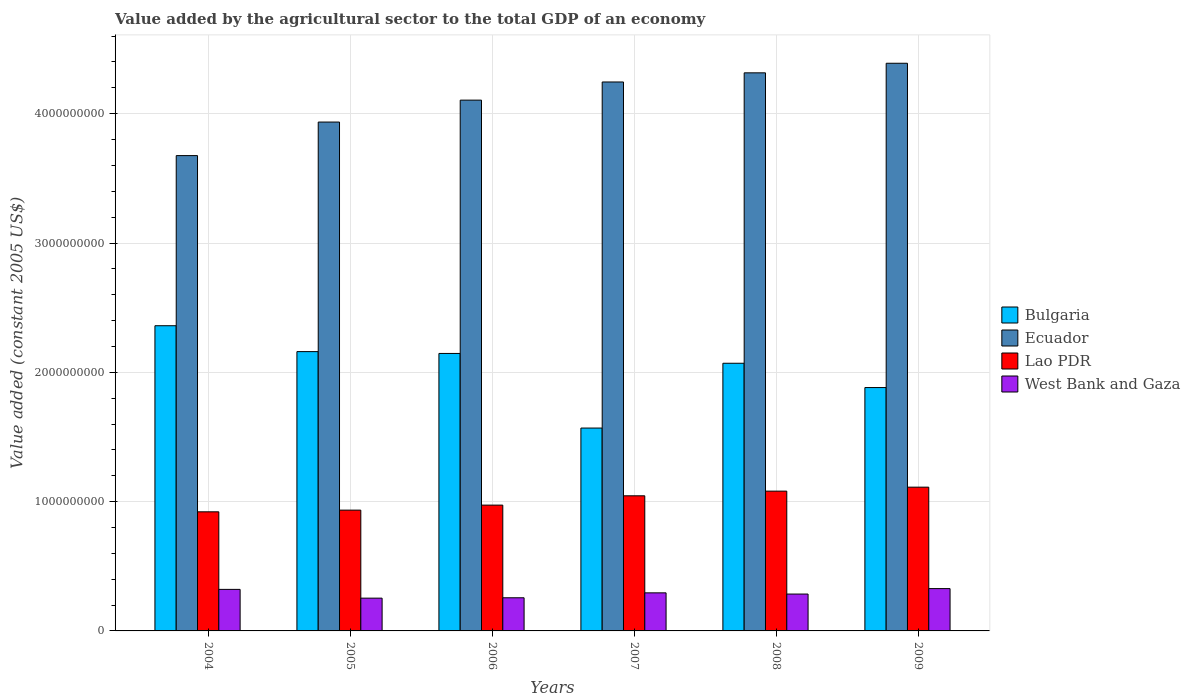How many different coloured bars are there?
Make the answer very short. 4. How many bars are there on the 4th tick from the left?
Your answer should be compact. 4. What is the label of the 3rd group of bars from the left?
Offer a terse response. 2006. What is the value added by the agricultural sector in Bulgaria in 2005?
Your answer should be very brief. 2.16e+09. Across all years, what is the maximum value added by the agricultural sector in Lao PDR?
Provide a succinct answer. 1.11e+09. Across all years, what is the minimum value added by the agricultural sector in Bulgaria?
Your answer should be very brief. 1.57e+09. In which year was the value added by the agricultural sector in Bulgaria minimum?
Your answer should be very brief. 2007. What is the total value added by the agricultural sector in Ecuador in the graph?
Give a very brief answer. 2.47e+1. What is the difference between the value added by the agricultural sector in Bulgaria in 2004 and that in 2007?
Ensure brevity in your answer.  7.91e+08. What is the difference between the value added by the agricultural sector in Ecuador in 2007 and the value added by the agricultural sector in West Bank and Gaza in 2006?
Your answer should be compact. 3.99e+09. What is the average value added by the agricultural sector in Ecuador per year?
Provide a short and direct response. 4.11e+09. In the year 2007, what is the difference between the value added by the agricultural sector in Bulgaria and value added by the agricultural sector in Lao PDR?
Give a very brief answer. 5.24e+08. What is the ratio of the value added by the agricultural sector in Ecuador in 2004 to that in 2007?
Your answer should be very brief. 0.87. Is the difference between the value added by the agricultural sector in Bulgaria in 2004 and 2005 greater than the difference between the value added by the agricultural sector in Lao PDR in 2004 and 2005?
Offer a very short reply. Yes. What is the difference between the highest and the second highest value added by the agricultural sector in Lao PDR?
Give a very brief answer. 3.06e+07. What is the difference between the highest and the lowest value added by the agricultural sector in Bulgaria?
Ensure brevity in your answer.  7.91e+08. In how many years, is the value added by the agricultural sector in West Bank and Gaza greater than the average value added by the agricultural sector in West Bank and Gaza taken over all years?
Your answer should be compact. 3. Is the sum of the value added by the agricultural sector in West Bank and Gaza in 2007 and 2008 greater than the maximum value added by the agricultural sector in Lao PDR across all years?
Ensure brevity in your answer.  No. Is it the case that in every year, the sum of the value added by the agricultural sector in Bulgaria and value added by the agricultural sector in Lao PDR is greater than the sum of value added by the agricultural sector in West Bank and Gaza and value added by the agricultural sector in Ecuador?
Your answer should be very brief. Yes. What does the 1st bar from the left in 2006 represents?
Your answer should be compact. Bulgaria. What does the 3rd bar from the right in 2008 represents?
Give a very brief answer. Ecuador. Is it the case that in every year, the sum of the value added by the agricultural sector in Bulgaria and value added by the agricultural sector in West Bank and Gaza is greater than the value added by the agricultural sector in Lao PDR?
Offer a very short reply. Yes. How many years are there in the graph?
Your response must be concise. 6. How many legend labels are there?
Make the answer very short. 4. What is the title of the graph?
Your response must be concise. Value added by the agricultural sector to the total GDP of an economy. Does "China" appear as one of the legend labels in the graph?
Keep it short and to the point. No. What is the label or title of the X-axis?
Your answer should be compact. Years. What is the label or title of the Y-axis?
Your answer should be compact. Value added (constant 2005 US$). What is the Value added (constant 2005 US$) in Bulgaria in 2004?
Your response must be concise. 2.36e+09. What is the Value added (constant 2005 US$) of Ecuador in 2004?
Your answer should be compact. 3.68e+09. What is the Value added (constant 2005 US$) in Lao PDR in 2004?
Keep it short and to the point. 9.21e+08. What is the Value added (constant 2005 US$) in West Bank and Gaza in 2004?
Provide a short and direct response. 3.21e+08. What is the Value added (constant 2005 US$) in Bulgaria in 2005?
Ensure brevity in your answer.  2.16e+09. What is the Value added (constant 2005 US$) of Ecuador in 2005?
Your answer should be compact. 3.94e+09. What is the Value added (constant 2005 US$) of Lao PDR in 2005?
Make the answer very short. 9.34e+08. What is the Value added (constant 2005 US$) in West Bank and Gaza in 2005?
Give a very brief answer. 2.53e+08. What is the Value added (constant 2005 US$) in Bulgaria in 2006?
Your answer should be very brief. 2.15e+09. What is the Value added (constant 2005 US$) of Ecuador in 2006?
Make the answer very short. 4.10e+09. What is the Value added (constant 2005 US$) of Lao PDR in 2006?
Give a very brief answer. 9.73e+08. What is the Value added (constant 2005 US$) of West Bank and Gaza in 2006?
Offer a terse response. 2.56e+08. What is the Value added (constant 2005 US$) of Bulgaria in 2007?
Your response must be concise. 1.57e+09. What is the Value added (constant 2005 US$) of Ecuador in 2007?
Make the answer very short. 4.25e+09. What is the Value added (constant 2005 US$) in Lao PDR in 2007?
Your answer should be compact. 1.04e+09. What is the Value added (constant 2005 US$) in West Bank and Gaza in 2007?
Your answer should be very brief. 2.94e+08. What is the Value added (constant 2005 US$) of Bulgaria in 2008?
Your answer should be compact. 2.07e+09. What is the Value added (constant 2005 US$) in Ecuador in 2008?
Your response must be concise. 4.32e+09. What is the Value added (constant 2005 US$) in Lao PDR in 2008?
Offer a terse response. 1.08e+09. What is the Value added (constant 2005 US$) of West Bank and Gaza in 2008?
Provide a succinct answer. 2.85e+08. What is the Value added (constant 2005 US$) in Bulgaria in 2009?
Your answer should be compact. 1.88e+09. What is the Value added (constant 2005 US$) in Ecuador in 2009?
Provide a succinct answer. 4.39e+09. What is the Value added (constant 2005 US$) of Lao PDR in 2009?
Ensure brevity in your answer.  1.11e+09. What is the Value added (constant 2005 US$) in West Bank and Gaza in 2009?
Your answer should be compact. 3.27e+08. Across all years, what is the maximum Value added (constant 2005 US$) of Bulgaria?
Make the answer very short. 2.36e+09. Across all years, what is the maximum Value added (constant 2005 US$) of Ecuador?
Offer a very short reply. 4.39e+09. Across all years, what is the maximum Value added (constant 2005 US$) of Lao PDR?
Make the answer very short. 1.11e+09. Across all years, what is the maximum Value added (constant 2005 US$) in West Bank and Gaza?
Your response must be concise. 3.27e+08. Across all years, what is the minimum Value added (constant 2005 US$) of Bulgaria?
Your response must be concise. 1.57e+09. Across all years, what is the minimum Value added (constant 2005 US$) in Ecuador?
Give a very brief answer. 3.68e+09. Across all years, what is the minimum Value added (constant 2005 US$) of Lao PDR?
Give a very brief answer. 9.21e+08. Across all years, what is the minimum Value added (constant 2005 US$) of West Bank and Gaza?
Provide a succinct answer. 2.53e+08. What is the total Value added (constant 2005 US$) of Bulgaria in the graph?
Your response must be concise. 1.22e+1. What is the total Value added (constant 2005 US$) in Ecuador in the graph?
Your response must be concise. 2.47e+1. What is the total Value added (constant 2005 US$) of Lao PDR in the graph?
Ensure brevity in your answer.  6.07e+09. What is the total Value added (constant 2005 US$) in West Bank and Gaza in the graph?
Ensure brevity in your answer.  1.74e+09. What is the difference between the Value added (constant 2005 US$) in Bulgaria in 2004 and that in 2005?
Provide a succinct answer. 2.00e+08. What is the difference between the Value added (constant 2005 US$) in Ecuador in 2004 and that in 2005?
Offer a terse response. -2.59e+08. What is the difference between the Value added (constant 2005 US$) of Lao PDR in 2004 and that in 2005?
Your response must be concise. -1.30e+07. What is the difference between the Value added (constant 2005 US$) of West Bank and Gaza in 2004 and that in 2005?
Your response must be concise. 6.79e+07. What is the difference between the Value added (constant 2005 US$) in Bulgaria in 2004 and that in 2006?
Your answer should be very brief. 2.14e+08. What is the difference between the Value added (constant 2005 US$) in Ecuador in 2004 and that in 2006?
Offer a very short reply. -4.29e+08. What is the difference between the Value added (constant 2005 US$) in Lao PDR in 2004 and that in 2006?
Offer a very short reply. -5.19e+07. What is the difference between the Value added (constant 2005 US$) in West Bank and Gaza in 2004 and that in 2006?
Make the answer very short. 6.50e+07. What is the difference between the Value added (constant 2005 US$) of Bulgaria in 2004 and that in 2007?
Give a very brief answer. 7.91e+08. What is the difference between the Value added (constant 2005 US$) of Ecuador in 2004 and that in 2007?
Keep it short and to the point. -5.69e+08. What is the difference between the Value added (constant 2005 US$) in Lao PDR in 2004 and that in 2007?
Your response must be concise. -1.24e+08. What is the difference between the Value added (constant 2005 US$) of West Bank and Gaza in 2004 and that in 2007?
Your answer should be very brief. 2.69e+07. What is the difference between the Value added (constant 2005 US$) of Bulgaria in 2004 and that in 2008?
Your response must be concise. 2.90e+08. What is the difference between the Value added (constant 2005 US$) in Ecuador in 2004 and that in 2008?
Provide a short and direct response. -6.40e+08. What is the difference between the Value added (constant 2005 US$) in Lao PDR in 2004 and that in 2008?
Provide a short and direct response. -1.60e+08. What is the difference between the Value added (constant 2005 US$) of West Bank and Gaza in 2004 and that in 2008?
Offer a very short reply. 3.62e+07. What is the difference between the Value added (constant 2005 US$) of Bulgaria in 2004 and that in 2009?
Give a very brief answer. 4.78e+08. What is the difference between the Value added (constant 2005 US$) in Ecuador in 2004 and that in 2009?
Your response must be concise. -7.14e+08. What is the difference between the Value added (constant 2005 US$) of Lao PDR in 2004 and that in 2009?
Provide a succinct answer. -1.91e+08. What is the difference between the Value added (constant 2005 US$) of West Bank and Gaza in 2004 and that in 2009?
Offer a very short reply. -6.01e+06. What is the difference between the Value added (constant 2005 US$) in Bulgaria in 2005 and that in 2006?
Make the answer very short. 1.41e+07. What is the difference between the Value added (constant 2005 US$) of Ecuador in 2005 and that in 2006?
Give a very brief answer. -1.70e+08. What is the difference between the Value added (constant 2005 US$) in Lao PDR in 2005 and that in 2006?
Keep it short and to the point. -3.88e+07. What is the difference between the Value added (constant 2005 US$) of West Bank and Gaza in 2005 and that in 2006?
Your response must be concise. -2.89e+06. What is the difference between the Value added (constant 2005 US$) of Bulgaria in 2005 and that in 2007?
Keep it short and to the point. 5.91e+08. What is the difference between the Value added (constant 2005 US$) of Ecuador in 2005 and that in 2007?
Give a very brief answer. -3.10e+08. What is the difference between the Value added (constant 2005 US$) of Lao PDR in 2005 and that in 2007?
Your answer should be compact. -1.11e+08. What is the difference between the Value added (constant 2005 US$) in West Bank and Gaza in 2005 and that in 2007?
Offer a very short reply. -4.09e+07. What is the difference between the Value added (constant 2005 US$) of Bulgaria in 2005 and that in 2008?
Offer a very short reply. 9.00e+07. What is the difference between the Value added (constant 2005 US$) in Ecuador in 2005 and that in 2008?
Provide a succinct answer. -3.81e+08. What is the difference between the Value added (constant 2005 US$) of Lao PDR in 2005 and that in 2008?
Your response must be concise. -1.47e+08. What is the difference between the Value added (constant 2005 US$) in West Bank and Gaza in 2005 and that in 2008?
Your response must be concise. -3.17e+07. What is the difference between the Value added (constant 2005 US$) in Bulgaria in 2005 and that in 2009?
Give a very brief answer. 2.78e+08. What is the difference between the Value added (constant 2005 US$) in Ecuador in 2005 and that in 2009?
Your answer should be compact. -4.55e+08. What is the difference between the Value added (constant 2005 US$) of Lao PDR in 2005 and that in 2009?
Ensure brevity in your answer.  -1.78e+08. What is the difference between the Value added (constant 2005 US$) of West Bank and Gaza in 2005 and that in 2009?
Your response must be concise. -7.39e+07. What is the difference between the Value added (constant 2005 US$) of Bulgaria in 2006 and that in 2007?
Offer a terse response. 5.77e+08. What is the difference between the Value added (constant 2005 US$) of Ecuador in 2006 and that in 2007?
Ensure brevity in your answer.  -1.40e+08. What is the difference between the Value added (constant 2005 US$) of Lao PDR in 2006 and that in 2007?
Keep it short and to the point. -7.20e+07. What is the difference between the Value added (constant 2005 US$) of West Bank and Gaza in 2006 and that in 2007?
Offer a very short reply. -3.81e+07. What is the difference between the Value added (constant 2005 US$) in Bulgaria in 2006 and that in 2008?
Your response must be concise. 7.59e+07. What is the difference between the Value added (constant 2005 US$) in Ecuador in 2006 and that in 2008?
Your answer should be compact. -2.11e+08. What is the difference between the Value added (constant 2005 US$) in Lao PDR in 2006 and that in 2008?
Offer a very short reply. -1.08e+08. What is the difference between the Value added (constant 2005 US$) of West Bank and Gaza in 2006 and that in 2008?
Provide a succinct answer. -2.88e+07. What is the difference between the Value added (constant 2005 US$) in Bulgaria in 2006 and that in 2009?
Make the answer very short. 2.64e+08. What is the difference between the Value added (constant 2005 US$) of Ecuador in 2006 and that in 2009?
Provide a succinct answer. -2.85e+08. What is the difference between the Value added (constant 2005 US$) in Lao PDR in 2006 and that in 2009?
Make the answer very short. -1.39e+08. What is the difference between the Value added (constant 2005 US$) in West Bank and Gaza in 2006 and that in 2009?
Give a very brief answer. -7.10e+07. What is the difference between the Value added (constant 2005 US$) in Bulgaria in 2007 and that in 2008?
Provide a succinct answer. -5.01e+08. What is the difference between the Value added (constant 2005 US$) in Ecuador in 2007 and that in 2008?
Keep it short and to the point. -7.08e+07. What is the difference between the Value added (constant 2005 US$) of Lao PDR in 2007 and that in 2008?
Provide a short and direct response. -3.61e+07. What is the difference between the Value added (constant 2005 US$) in West Bank and Gaza in 2007 and that in 2008?
Offer a very short reply. 9.26e+06. What is the difference between the Value added (constant 2005 US$) in Bulgaria in 2007 and that in 2009?
Your answer should be very brief. -3.13e+08. What is the difference between the Value added (constant 2005 US$) of Ecuador in 2007 and that in 2009?
Provide a succinct answer. -1.45e+08. What is the difference between the Value added (constant 2005 US$) in Lao PDR in 2007 and that in 2009?
Your response must be concise. -6.67e+07. What is the difference between the Value added (constant 2005 US$) of West Bank and Gaza in 2007 and that in 2009?
Make the answer very short. -3.29e+07. What is the difference between the Value added (constant 2005 US$) in Bulgaria in 2008 and that in 2009?
Ensure brevity in your answer.  1.88e+08. What is the difference between the Value added (constant 2005 US$) of Ecuador in 2008 and that in 2009?
Your answer should be compact. -7.40e+07. What is the difference between the Value added (constant 2005 US$) in Lao PDR in 2008 and that in 2009?
Keep it short and to the point. -3.06e+07. What is the difference between the Value added (constant 2005 US$) in West Bank and Gaza in 2008 and that in 2009?
Offer a terse response. -4.22e+07. What is the difference between the Value added (constant 2005 US$) of Bulgaria in 2004 and the Value added (constant 2005 US$) of Ecuador in 2005?
Your response must be concise. -1.58e+09. What is the difference between the Value added (constant 2005 US$) in Bulgaria in 2004 and the Value added (constant 2005 US$) in Lao PDR in 2005?
Make the answer very short. 1.43e+09. What is the difference between the Value added (constant 2005 US$) of Bulgaria in 2004 and the Value added (constant 2005 US$) of West Bank and Gaza in 2005?
Keep it short and to the point. 2.11e+09. What is the difference between the Value added (constant 2005 US$) in Ecuador in 2004 and the Value added (constant 2005 US$) in Lao PDR in 2005?
Offer a very short reply. 2.74e+09. What is the difference between the Value added (constant 2005 US$) of Ecuador in 2004 and the Value added (constant 2005 US$) of West Bank and Gaza in 2005?
Make the answer very short. 3.42e+09. What is the difference between the Value added (constant 2005 US$) in Lao PDR in 2004 and the Value added (constant 2005 US$) in West Bank and Gaza in 2005?
Offer a very short reply. 6.68e+08. What is the difference between the Value added (constant 2005 US$) in Bulgaria in 2004 and the Value added (constant 2005 US$) in Ecuador in 2006?
Your response must be concise. -1.74e+09. What is the difference between the Value added (constant 2005 US$) in Bulgaria in 2004 and the Value added (constant 2005 US$) in Lao PDR in 2006?
Offer a terse response. 1.39e+09. What is the difference between the Value added (constant 2005 US$) of Bulgaria in 2004 and the Value added (constant 2005 US$) of West Bank and Gaza in 2006?
Provide a short and direct response. 2.10e+09. What is the difference between the Value added (constant 2005 US$) in Ecuador in 2004 and the Value added (constant 2005 US$) in Lao PDR in 2006?
Provide a short and direct response. 2.70e+09. What is the difference between the Value added (constant 2005 US$) in Ecuador in 2004 and the Value added (constant 2005 US$) in West Bank and Gaza in 2006?
Ensure brevity in your answer.  3.42e+09. What is the difference between the Value added (constant 2005 US$) of Lao PDR in 2004 and the Value added (constant 2005 US$) of West Bank and Gaza in 2006?
Make the answer very short. 6.65e+08. What is the difference between the Value added (constant 2005 US$) of Bulgaria in 2004 and the Value added (constant 2005 US$) of Ecuador in 2007?
Your answer should be very brief. -1.88e+09. What is the difference between the Value added (constant 2005 US$) of Bulgaria in 2004 and the Value added (constant 2005 US$) of Lao PDR in 2007?
Offer a very short reply. 1.32e+09. What is the difference between the Value added (constant 2005 US$) in Bulgaria in 2004 and the Value added (constant 2005 US$) in West Bank and Gaza in 2007?
Your answer should be compact. 2.07e+09. What is the difference between the Value added (constant 2005 US$) in Ecuador in 2004 and the Value added (constant 2005 US$) in Lao PDR in 2007?
Your response must be concise. 2.63e+09. What is the difference between the Value added (constant 2005 US$) in Ecuador in 2004 and the Value added (constant 2005 US$) in West Bank and Gaza in 2007?
Your answer should be very brief. 3.38e+09. What is the difference between the Value added (constant 2005 US$) in Lao PDR in 2004 and the Value added (constant 2005 US$) in West Bank and Gaza in 2007?
Give a very brief answer. 6.27e+08. What is the difference between the Value added (constant 2005 US$) of Bulgaria in 2004 and the Value added (constant 2005 US$) of Ecuador in 2008?
Provide a short and direct response. -1.96e+09. What is the difference between the Value added (constant 2005 US$) of Bulgaria in 2004 and the Value added (constant 2005 US$) of Lao PDR in 2008?
Make the answer very short. 1.28e+09. What is the difference between the Value added (constant 2005 US$) in Bulgaria in 2004 and the Value added (constant 2005 US$) in West Bank and Gaza in 2008?
Make the answer very short. 2.08e+09. What is the difference between the Value added (constant 2005 US$) of Ecuador in 2004 and the Value added (constant 2005 US$) of Lao PDR in 2008?
Make the answer very short. 2.59e+09. What is the difference between the Value added (constant 2005 US$) in Ecuador in 2004 and the Value added (constant 2005 US$) in West Bank and Gaza in 2008?
Your answer should be very brief. 3.39e+09. What is the difference between the Value added (constant 2005 US$) in Lao PDR in 2004 and the Value added (constant 2005 US$) in West Bank and Gaza in 2008?
Ensure brevity in your answer.  6.36e+08. What is the difference between the Value added (constant 2005 US$) of Bulgaria in 2004 and the Value added (constant 2005 US$) of Ecuador in 2009?
Your response must be concise. -2.03e+09. What is the difference between the Value added (constant 2005 US$) in Bulgaria in 2004 and the Value added (constant 2005 US$) in Lao PDR in 2009?
Offer a terse response. 1.25e+09. What is the difference between the Value added (constant 2005 US$) in Bulgaria in 2004 and the Value added (constant 2005 US$) in West Bank and Gaza in 2009?
Your answer should be very brief. 2.03e+09. What is the difference between the Value added (constant 2005 US$) in Ecuador in 2004 and the Value added (constant 2005 US$) in Lao PDR in 2009?
Offer a terse response. 2.56e+09. What is the difference between the Value added (constant 2005 US$) of Ecuador in 2004 and the Value added (constant 2005 US$) of West Bank and Gaza in 2009?
Give a very brief answer. 3.35e+09. What is the difference between the Value added (constant 2005 US$) of Lao PDR in 2004 and the Value added (constant 2005 US$) of West Bank and Gaza in 2009?
Keep it short and to the point. 5.94e+08. What is the difference between the Value added (constant 2005 US$) of Bulgaria in 2005 and the Value added (constant 2005 US$) of Ecuador in 2006?
Give a very brief answer. -1.94e+09. What is the difference between the Value added (constant 2005 US$) in Bulgaria in 2005 and the Value added (constant 2005 US$) in Lao PDR in 2006?
Offer a very short reply. 1.19e+09. What is the difference between the Value added (constant 2005 US$) of Bulgaria in 2005 and the Value added (constant 2005 US$) of West Bank and Gaza in 2006?
Your response must be concise. 1.90e+09. What is the difference between the Value added (constant 2005 US$) of Ecuador in 2005 and the Value added (constant 2005 US$) of Lao PDR in 2006?
Offer a very short reply. 2.96e+09. What is the difference between the Value added (constant 2005 US$) of Ecuador in 2005 and the Value added (constant 2005 US$) of West Bank and Gaza in 2006?
Give a very brief answer. 3.68e+09. What is the difference between the Value added (constant 2005 US$) in Lao PDR in 2005 and the Value added (constant 2005 US$) in West Bank and Gaza in 2006?
Offer a terse response. 6.78e+08. What is the difference between the Value added (constant 2005 US$) of Bulgaria in 2005 and the Value added (constant 2005 US$) of Ecuador in 2007?
Provide a short and direct response. -2.09e+09. What is the difference between the Value added (constant 2005 US$) of Bulgaria in 2005 and the Value added (constant 2005 US$) of Lao PDR in 2007?
Provide a short and direct response. 1.12e+09. What is the difference between the Value added (constant 2005 US$) in Bulgaria in 2005 and the Value added (constant 2005 US$) in West Bank and Gaza in 2007?
Your answer should be compact. 1.87e+09. What is the difference between the Value added (constant 2005 US$) in Ecuador in 2005 and the Value added (constant 2005 US$) in Lao PDR in 2007?
Make the answer very short. 2.89e+09. What is the difference between the Value added (constant 2005 US$) of Ecuador in 2005 and the Value added (constant 2005 US$) of West Bank and Gaza in 2007?
Give a very brief answer. 3.64e+09. What is the difference between the Value added (constant 2005 US$) of Lao PDR in 2005 and the Value added (constant 2005 US$) of West Bank and Gaza in 2007?
Provide a succinct answer. 6.40e+08. What is the difference between the Value added (constant 2005 US$) in Bulgaria in 2005 and the Value added (constant 2005 US$) in Ecuador in 2008?
Offer a terse response. -2.16e+09. What is the difference between the Value added (constant 2005 US$) of Bulgaria in 2005 and the Value added (constant 2005 US$) of Lao PDR in 2008?
Provide a succinct answer. 1.08e+09. What is the difference between the Value added (constant 2005 US$) in Bulgaria in 2005 and the Value added (constant 2005 US$) in West Bank and Gaza in 2008?
Give a very brief answer. 1.87e+09. What is the difference between the Value added (constant 2005 US$) of Ecuador in 2005 and the Value added (constant 2005 US$) of Lao PDR in 2008?
Your answer should be compact. 2.85e+09. What is the difference between the Value added (constant 2005 US$) of Ecuador in 2005 and the Value added (constant 2005 US$) of West Bank and Gaza in 2008?
Offer a terse response. 3.65e+09. What is the difference between the Value added (constant 2005 US$) in Lao PDR in 2005 and the Value added (constant 2005 US$) in West Bank and Gaza in 2008?
Your response must be concise. 6.49e+08. What is the difference between the Value added (constant 2005 US$) in Bulgaria in 2005 and the Value added (constant 2005 US$) in Ecuador in 2009?
Provide a short and direct response. -2.23e+09. What is the difference between the Value added (constant 2005 US$) of Bulgaria in 2005 and the Value added (constant 2005 US$) of Lao PDR in 2009?
Give a very brief answer. 1.05e+09. What is the difference between the Value added (constant 2005 US$) in Bulgaria in 2005 and the Value added (constant 2005 US$) in West Bank and Gaza in 2009?
Give a very brief answer. 1.83e+09. What is the difference between the Value added (constant 2005 US$) of Ecuador in 2005 and the Value added (constant 2005 US$) of Lao PDR in 2009?
Keep it short and to the point. 2.82e+09. What is the difference between the Value added (constant 2005 US$) in Ecuador in 2005 and the Value added (constant 2005 US$) in West Bank and Gaza in 2009?
Your answer should be compact. 3.61e+09. What is the difference between the Value added (constant 2005 US$) of Lao PDR in 2005 and the Value added (constant 2005 US$) of West Bank and Gaza in 2009?
Give a very brief answer. 6.07e+08. What is the difference between the Value added (constant 2005 US$) of Bulgaria in 2006 and the Value added (constant 2005 US$) of Ecuador in 2007?
Your response must be concise. -2.10e+09. What is the difference between the Value added (constant 2005 US$) in Bulgaria in 2006 and the Value added (constant 2005 US$) in Lao PDR in 2007?
Offer a terse response. 1.10e+09. What is the difference between the Value added (constant 2005 US$) of Bulgaria in 2006 and the Value added (constant 2005 US$) of West Bank and Gaza in 2007?
Offer a terse response. 1.85e+09. What is the difference between the Value added (constant 2005 US$) of Ecuador in 2006 and the Value added (constant 2005 US$) of Lao PDR in 2007?
Provide a succinct answer. 3.06e+09. What is the difference between the Value added (constant 2005 US$) in Ecuador in 2006 and the Value added (constant 2005 US$) in West Bank and Gaza in 2007?
Your answer should be compact. 3.81e+09. What is the difference between the Value added (constant 2005 US$) in Lao PDR in 2006 and the Value added (constant 2005 US$) in West Bank and Gaza in 2007?
Your answer should be very brief. 6.79e+08. What is the difference between the Value added (constant 2005 US$) in Bulgaria in 2006 and the Value added (constant 2005 US$) in Ecuador in 2008?
Your answer should be compact. -2.17e+09. What is the difference between the Value added (constant 2005 US$) of Bulgaria in 2006 and the Value added (constant 2005 US$) of Lao PDR in 2008?
Your answer should be very brief. 1.06e+09. What is the difference between the Value added (constant 2005 US$) in Bulgaria in 2006 and the Value added (constant 2005 US$) in West Bank and Gaza in 2008?
Provide a short and direct response. 1.86e+09. What is the difference between the Value added (constant 2005 US$) in Ecuador in 2006 and the Value added (constant 2005 US$) in Lao PDR in 2008?
Provide a succinct answer. 3.02e+09. What is the difference between the Value added (constant 2005 US$) of Ecuador in 2006 and the Value added (constant 2005 US$) of West Bank and Gaza in 2008?
Provide a succinct answer. 3.82e+09. What is the difference between the Value added (constant 2005 US$) in Lao PDR in 2006 and the Value added (constant 2005 US$) in West Bank and Gaza in 2008?
Offer a very short reply. 6.88e+08. What is the difference between the Value added (constant 2005 US$) in Bulgaria in 2006 and the Value added (constant 2005 US$) in Ecuador in 2009?
Provide a short and direct response. -2.24e+09. What is the difference between the Value added (constant 2005 US$) in Bulgaria in 2006 and the Value added (constant 2005 US$) in Lao PDR in 2009?
Your response must be concise. 1.03e+09. What is the difference between the Value added (constant 2005 US$) in Bulgaria in 2006 and the Value added (constant 2005 US$) in West Bank and Gaza in 2009?
Your answer should be very brief. 1.82e+09. What is the difference between the Value added (constant 2005 US$) of Ecuador in 2006 and the Value added (constant 2005 US$) of Lao PDR in 2009?
Your answer should be compact. 2.99e+09. What is the difference between the Value added (constant 2005 US$) in Ecuador in 2006 and the Value added (constant 2005 US$) in West Bank and Gaza in 2009?
Give a very brief answer. 3.78e+09. What is the difference between the Value added (constant 2005 US$) of Lao PDR in 2006 and the Value added (constant 2005 US$) of West Bank and Gaza in 2009?
Keep it short and to the point. 6.46e+08. What is the difference between the Value added (constant 2005 US$) in Bulgaria in 2007 and the Value added (constant 2005 US$) in Ecuador in 2008?
Your response must be concise. -2.75e+09. What is the difference between the Value added (constant 2005 US$) of Bulgaria in 2007 and the Value added (constant 2005 US$) of Lao PDR in 2008?
Your answer should be very brief. 4.88e+08. What is the difference between the Value added (constant 2005 US$) of Bulgaria in 2007 and the Value added (constant 2005 US$) of West Bank and Gaza in 2008?
Your answer should be compact. 1.28e+09. What is the difference between the Value added (constant 2005 US$) of Ecuador in 2007 and the Value added (constant 2005 US$) of Lao PDR in 2008?
Give a very brief answer. 3.16e+09. What is the difference between the Value added (constant 2005 US$) of Ecuador in 2007 and the Value added (constant 2005 US$) of West Bank and Gaza in 2008?
Provide a succinct answer. 3.96e+09. What is the difference between the Value added (constant 2005 US$) of Lao PDR in 2007 and the Value added (constant 2005 US$) of West Bank and Gaza in 2008?
Provide a succinct answer. 7.60e+08. What is the difference between the Value added (constant 2005 US$) of Bulgaria in 2007 and the Value added (constant 2005 US$) of Ecuador in 2009?
Provide a short and direct response. -2.82e+09. What is the difference between the Value added (constant 2005 US$) in Bulgaria in 2007 and the Value added (constant 2005 US$) in Lao PDR in 2009?
Make the answer very short. 4.57e+08. What is the difference between the Value added (constant 2005 US$) in Bulgaria in 2007 and the Value added (constant 2005 US$) in West Bank and Gaza in 2009?
Offer a terse response. 1.24e+09. What is the difference between the Value added (constant 2005 US$) in Ecuador in 2007 and the Value added (constant 2005 US$) in Lao PDR in 2009?
Provide a short and direct response. 3.13e+09. What is the difference between the Value added (constant 2005 US$) of Ecuador in 2007 and the Value added (constant 2005 US$) of West Bank and Gaza in 2009?
Make the answer very short. 3.92e+09. What is the difference between the Value added (constant 2005 US$) in Lao PDR in 2007 and the Value added (constant 2005 US$) in West Bank and Gaza in 2009?
Your answer should be very brief. 7.18e+08. What is the difference between the Value added (constant 2005 US$) of Bulgaria in 2008 and the Value added (constant 2005 US$) of Ecuador in 2009?
Provide a short and direct response. -2.32e+09. What is the difference between the Value added (constant 2005 US$) in Bulgaria in 2008 and the Value added (constant 2005 US$) in Lao PDR in 2009?
Provide a short and direct response. 9.58e+08. What is the difference between the Value added (constant 2005 US$) in Bulgaria in 2008 and the Value added (constant 2005 US$) in West Bank and Gaza in 2009?
Provide a short and direct response. 1.74e+09. What is the difference between the Value added (constant 2005 US$) in Ecuador in 2008 and the Value added (constant 2005 US$) in Lao PDR in 2009?
Your answer should be compact. 3.20e+09. What is the difference between the Value added (constant 2005 US$) in Ecuador in 2008 and the Value added (constant 2005 US$) in West Bank and Gaza in 2009?
Offer a terse response. 3.99e+09. What is the difference between the Value added (constant 2005 US$) of Lao PDR in 2008 and the Value added (constant 2005 US$) of West Bank and Gaza in 2009?
Your answer should be very brief. 7.54e+08. What is the average Value added (constant 2005 US$) in Bulgaria per year?
Keep it short and to the point. 2.03e+09. What is the average Value added (constant 2005 US$) of Ecuador per year?
Your answer should be compact. 4.11e+09. What is the average Value added (constant 2005 US$) in Lao PDR per year?
Provide a short and direct response. 1.01e+09. What is the average Value added (constant 2005 US$) of West Bank and Gaza per year?
Offer a terse response. 2.90e+08. In the year 2004, what is the difference between the Value added (constant 2005 US$) in Bulgaria and Value added (constant 2005 US$) in Ecuador?
Give a very brief answer. -1.32e+09. In the year 2004, what is the difference between the Value added (constant 2005 US$) in Bulgaria and Value added (constant 2005 US$) in Lao PDR?
Provide a succinct answer. 1.44e+09. In the year 2004, what is the difference between the Value added (constant 2005 US$) of Bulgaria and Value added (constant 2005 US$) of West Bank and Gaza?
Offer a very short reply. 2.04e+09. In the year 2004, what is the difference between the Value added (constant 2005 US$) of Ecuador and Value added (constant 2005 US$) of Lao PDR?
Your answer should be compact. 2.75e+09. In the year 2004, what is the difference between the Value added (constant 2005 US$) in Ecuador and Value added (constant 2005 US$) in West Bank and Gaza?
Provide a succinct answer. 3.35e+09. In the year 2004, what is the difference between the Value added (constant 2005 US$) of Lao PDR and Value added (constant 2005 US$) of West Bank and Gaza?
Give a very brief answer. 6.00e+08. In the year 2005, what is the difference between the Value added (constant 2005 US$) of Bulgaria and Value added (constant 2005 US$) of Ecuador?
Offer a terse response. -1.78e+09. In the year 2005, what is the difference between the Value added (constant 2005 US$) in Bulgaria and Value added (constant 2005 US$) in Lao PDR?
Provide a short and direct response. 1.23e+09. In the year 2005, what is the difference between the Value added (constant 2005 US$) of Bulgaria and Value added (constant 2005 US$) of West Bank and Gaza?
Your answer should be compact. 1.91e+09. In the year 2005, what is the difference between the Value added (constant 2005 US$) of Ecuador and Value added (constant 2005 US$) of Lao PDR?
Your answer should be compact. 3.00e+09. In the year 2005, what is the difference between the Value added (constant 2005 US$) in Ecuador and Value added (constant 2005 US$) in West Bank and Gaza?
Keep it short and to the point. 3.68e+09. In the year 2005, what is the difference between the Value added (constant 2005 US$) of Lao PDR and Value added (constant 2005 US$) of West Bank and Gaza?
Your response must be concise. 6.81e+08. In the year 2006, what is the difference between the Value added (constant 2005 US$) of Bulgaria and Value added (constant 2005 US$) of Ecuador?
Your answer should be very brief. -1.96e+09. In the year 2006, what is the difference between the Value added (constant 2005 US$) in Bulgaria and Value added (constant 2005 US$) in Lao PDR?
Offer a terse response. 1.17e+09. In the year 2006, what is the difference between the Value added (constant 2005 US$) of Bulgaria and Value added (constant 2005 US$) of West Bank and Gaza?
Provide a short and direct response. 1.89e+09. In the year 2006, what is the difference between the Value added (constant 2005 US$) in Ecuador and Value added (constant 2005 US$) in Lao PDR?
Your answer should be compact. 3.13e+09. In the year 2006, what is the difference between the Value added (constant 2005 US$) of Ecuador and Value added (constant 2005 US$) of West Bank and Gaza?
Offer a very short reply. 3.85e+09. In the year 2006, what is the difference between the Value added (constant 2005 US$) of Lao PDR and Value added (constant 2005 US$) of West Bank and Gaza?
Ensure brevity in your answer.  7.17e+08. In the year 2007, what is the difference between the Value added (constant 2005 US$) in Bulgaria and Value added (constant 2005 US$) in Ecuador?
Your answer should be very brief. -2.68e+09. In the year 2007, what is the difference between the Value added (constant 2005 US$) of Bulgaria and Value added (constant 2005 US$) of Lao PDR?
Ensure brevity in your answer.  5.24e+08. In the year 2007, what is the difference between the Value added (constant 2005 US$) in Bulgaria and Value added (constant 2005 US$) in West Bank and Gaza?
Keep it short and to the point. 1.27e+09. In the year 2007, what is the difference between the Value added (constant 2005 US$) in Ecuador and Value added (constant 2005 US$) in Lao PDR?
Offer a terse response. 3.20e+09. In the year 2007, what is the difference between the Value added (constant 2005 US$) of Ecuador and Value added (constant 2005 US$) of West Bank and Gaza?
Ensure brevity in your answer.  3.95e+09. In the year 2007, what is the difference between the Value added (constant 2005 US$) of Lao PDR and Value added (constant 2005 US$) of West Bank and Gaza?
Give a very brief answer. 7.51e+08. In the year 2008, what is the difference between the Value added (constant 2005 US$) of Bulgaria and Value added (constant 2005 US$) of Ecuador?
Keep it short and to the point. -2.25e+09. In the year 2008, what is the difference between the Value added (constant 2005 US$) in Bulgaria and Value added (constant 2005 US$) in Lao PDR?
Provide a succinct answer. 9.89e+08. In the year 2008, what is the difference between the Value added (constant 2005 US$) in Bulgaria and Value added (constant 2005 US$) in West Bank and Gaza?
Offer a very short reply. 1.78e+09. In the year 2008, what is the difference between the Value added (constant 2005 US$) in Ecuador and Value added (constant 2005 US$) in Lao PDR?
Your answer should be very brief. 3.23e+09. In the year 2008, what is the difference between the Value added (constant 2005 US$) of Ecuador and Value added (constant 2005 US$) of West Bank and Gaza?
Your answer should be compact. 4.03e+09. In the year 2008, what is the difference between the Value added (constant 2005 US$) in Lao PDR and Value added (constant 2005 US$) in West Bank and Gaza?
Your response must be concise. 7.96e+08. In the year 2009, what is the difference between the Value added (constant 2005 US$) of Bulgaria and Value added (constant 2005 US$) of Ecuador?
Provide a short and direct response. -2.51e+09. In the year 2009, what is the difference between the Value added (constant 2005 US$) in Bulgaria and Value added (constant 2005 US$) in Lao PDR?
Offer a very short reply. 7.70e+08. In the year 2009, what is the difference between the Value added (constant 2005 US$) in Bulgaria and Value added (constant 2005 US$) in West Bank and Gaza?
Offer a terse response. 1.55e+09. In the year 2009, what is the difference between the Value added (constant 2005 US$) of Ecuador and Value added (constant 2005 US$) of Lao PDR?
Give a very brief answer. 3.28e+09. In the year 2009, what is the difference between the Value added (constant 2005 US$) of Ecuador and Value added (constant 2005 US$) of West Bank and Gaza?
Ensure brevity in your answer.  4.06e+09. In the year 2009, what is the difference between the Value added (constant 2005 US$) of Lao PDR and Value added (constant 2005 US$) of West Bank and Gaza?
Provide a short and direct response. 7.84e+08. What is the ratio of the Value added (constant 2005 US$) of Bulgaria in 2004 to that in 2005?
Offer a very short reply. 1.09. What is the ratio of the Value added (constant 2005 US$) in Ecuador in 2004 to that in 2005?
Your response must be concise. 0.93. What is the ratio of the Value added (constant 2005 US$) in West Bank and Gaza in 2004 to that in 2005?
Give a very brief answer. 1.27. What is the ratio of the Value added (constant 2005 US$) in Bulgaria in 2004 to that in 2006?
Your response must be concise. 1.1. What is the ratio of the Value added (constant 2005 US$) of Ecuador in 2004 to that in 2006?
Ensure brevity in your answer.  0.9. What is the ratio of the Value added (constant 2005 US$) in Lao PDR in 2004 to that in 2006?
Give a very brief answer. 0.95. What is the ratio of the Value added (constant 2005 US$) of West Bank and Gaza in 2004 to that in 2006?
Ensure brevity in your answer.  1.25. What is the ratio of the Value added (constant 2005 US$) in Bulgaria in 2004 to that in 2007?
Provide a succinct answer. 1.5. What is the ratio of the Value added (constant 2005 US$) of Ecuador in 2004 to that in 2007?
Provide a short and direct response. 0.87. What is the ratio of the Value added (constant 2005 US$) of Lao PDR in 2004 to that in 2007?
Provide a succinct answer. 0.88. What is the ratio of the Value added (constant 2005 US$) of West Bank and Gaza in 2004 to that in 2007?
Ensure brevity in your answer.  1.09. What is the ratio of the Value added (constant 2005 US$) of Bulgaria in 2004 to that in 2008?
Keep it short and to the point. 1.14. What is the ratio of the Value added (constant 2005 US$) of Ecuador in 2004 to that in 2008?
Ensure brevity in your answer.  0.85. What is the ratio of the Value added (constant 2005 US$) in Lao PDR in 2004 to that in 2008?
Provide a short and direct response. 0.85. What is the ratio of the Value added (constant 2005 US$) in West Bank and Gaza in 2004 to that in 2008?
Provide a succinct answer. 1.13. What is the ratio of the Value added (constant 2005 US$) of Bulgaria in 2004 to that in 2009?
Keep it short and to the point. 1.25. What is the ratio of the Value added (constant 2005 US$) of Ecuador in 2004 to that in 2009?
Keep it short and to the point. 0.84. What is the ratio of the Value added (constant 2005 US$) in Lao PDR in 2004 to that in 2009?
Your answer should be very brief. 0.83. What is the ratio of the Value added (constant 2005 US$) of West Bank and Gaza in 2004 to that in 2009?
Give a very brief answer. 0.98. What is the ratio of the Value added (constant 2005 US$) in Bulgaria in 2005 to that in 2006?
Give a very brief answer. 1.01. What is the ratio of the Value added (constant 2005 US$) in Ecuador in 2005 to that in 2006?
Give a very brief answer. 0.96. What is the ratio of the Value added (constant 2005 US$) of Lao PDR in 2005 to that in 2006?
Make the answer very short. 0.96. What is the ratio of the Value added (constant 2005 US$) of West Bank and Gaza in 2005 to that in 2006?
Keep it short and to the point. 0.99. What is the ratio of the Value added (constant 2005 US$) in Bulgaria in 2005 to that in 2007?
Provide a succinct answer. 1.38. What is the ratio of the Value added (constant 2005 US$) in Ecuador in 2005 to that in 2007?
Provide a succinct answer. 0.93. What is the ratio of the Value added (constant 2005 US$) in Lao PDR in 2005 to that in 2007?
Provide a short and direct response. 0.89. What is the ratio of the Value added (constant 2005 US$) of West Bank and Gaza in 2005 to that in 2007?
Your answer should be compact. 0.86. What is the ratio of the Value added (constant 2005 US$) in Bulgaria in 2005 to that in 2008?
Offer a terse response. 1.04. What is the ratio of the Value added (constant 2005 US$) in Ecuador in 2005 to that in 2008?
Your answer should be very brief. 0.91. What is the ratio of the Value added (constant 2005 US$) in Lao PDR in 2005 to that in 2008?
Keep it short and to the point. 0.86. What is the ratio of the Value added (constant 2005 US$) in Bulgaria in 2005 to that in 2009?
Your answer should be compact. 1.15. What is the ratio of the Value added (constant 2005 US$) in Ecuador in 2005 to that in 2009?
Give a very brief answer. 0.9. What is the ratio of the Value added (constant 2005 US$) of Lao PDR in 2005 to that in 2009?
Your answer should be very brief. 0.84. What is the ratio of the Value added (constant 2005 US$) in West Bank and Gaza in 2005 to that in 2009?
Provide a short and direct response. 0.77. What is the ratio of the Value added (constant 2005 US$) in Bulgaria in 2006 to that in 2007?
Your response must be concise. 1.37. What is the ratio of the Value added (constant 2005 US$) in Ecuador in 2006 to that in 2007?
Offer a very short reply. 0.97. What is the ratio of the Value added (constant 2005 US$) in Lao PDR in 2006 to that in 2007?
Your answer should be compact. 0.93. What is the ratio of the Value added (constant 2005 US$) of West Bank and Gaza in 2006 to that in 2007?
Your answer should be compact. 0.87. What is the ratio of the Value added (constant 2005 US$) of Bulgaria in 2006 to that in 2008?
Offer a very short reply. 1.04. What is the ratio of the Value added (constant 2005 US$) in Ecuador in 2006 to that in 2008?
Offer a very short reply. 0.95. What is the ratio of the Value added (constant 2005 US$) in Lao PDR in 2006 to that in 2008?
Ensure brevity in your answer.  0.9. What is the ratio of the Value added (constant 2005 US$) of West Bank and Gaza in 2006 to that in 2008?
Provide a short and direct response. 0.9. What is the ratio of the Value added (constant 2005 US$) of Bulgaria in 2006 to that in 2009?
Offer a terse response. 1.14. What is the ratio of the Value added (constant 2005 US$) of Ecuador in 2006 to that in 2009?
Your answer should be very brief. 0.94. What is the ratio of the Value added (constant 2005 US$) in Lao PDR in 2006 to that in 2009?
Make the answer very short. 0.88. What is the ratio of the Value added (constant 2005 US$) of West Bank and Gaza in 2006 to that in 2009?
Keep it short and to the point. 0.78. What is the ratio of the Value added (constant 2005 US$) in Bulgaria in 2007 to that in 2008?
Ensure brevity in your answer.  0.76. What is the ratio of the Value added (constant 2005 US$) of Ecuador in 2007 to that in 2008?
Give a very brief answer. 0.98. What is the ratio of the Value added (constant 2005 US$) of Lao PDR in 2007 to that in 2008?
Keep it short and to the point. 0.97. What is the ratio of the Value added (constant 2005 US$) in West Bank and Gaza in 2007 to that in 2008?
Offer a very short reply. 1.03. What is the ratio of the Value added (constant 2005 US$) of Bulgaria in 2007 to that in 2009?
Give a very brief answer. 0.83. What is the ratio of the Value added (constant 2005 US$) in Ecuador in 2007 to that in 2009?
Give a very brief answer. 0.97. What is the ratio of the Value added (constant 2005 US$) of Lao PDR in 2007 to that in 2009?
Provide a succinct answer. 0.94. What is the ratio of the Value added (constant 2005 US$) in West Bank and Gaza in 2007 to that in 2009?
Give a very brief answer. 0.9. What is the ratio of the Value added (constant 2005 US$) in Bulgaria in 2008 to that in 2009?
Your answer should be very brief. 1.1. What is the ratio of the Value added (constant 2005 US$) of Ecuador in 2008 to that in 2009?
Provide a succinct answer. 0.98. What is the ratio of the Value added (constant 2005 US$) of Lao PDR in 2008 to that in 2009?
Your answer should be compact. 0.97. What is the ratio of the Value added (constant 2005 US$) of West Bank and Gaza in 2008 to that in 2009?
Make the answer very short. 0.87. What is the difference between the highest and the second highest Value added (constant 2005 US$) in Bulgaria?
Your answer should be compact. 2.00e+08. What is the difference between the highest and the second highest Value added (constant 2005 US$) of Ecuador?
Your response must be concise. 7.40e+07. What is the difference between the highest and the second highest Value added (constant 2005 US$) of Lao PDR?
Offer a terse response. 3.06e+07. What is the difference between the highest and the second highest Value added (constant 2005 US$) in West Bank and Gaza?
Your response must be concise. 6.01e+06. What is the difference between the highest and the lowest Value added (constant 2005 US$) in Bulgaria?
Your answer should be compact. 7.91e+08. What is the difference between the highest and the lowest Value added (constant 2005 US$) in Ecuador?
Your response must be concise. 7.14e+08. What is the difference between the highest and the lowest Value added (constant 2005 US$) of Lao PDR?
Your answer should be very brief. 1.91e+08. What is the difference between the highest and the lowest Value added (constant 2005 US$) in West Bank and Gaza?
Provide a succinct answer. 7.39e+07. 